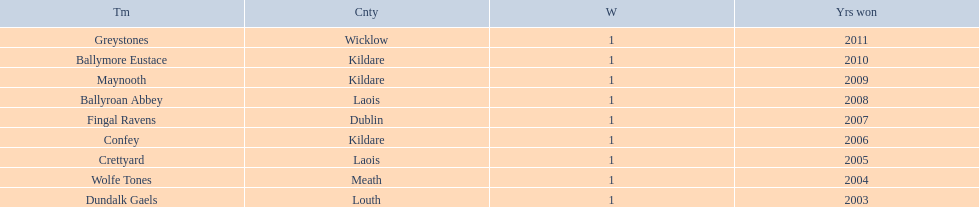Which team won after ballymore eustace? Greystones. 